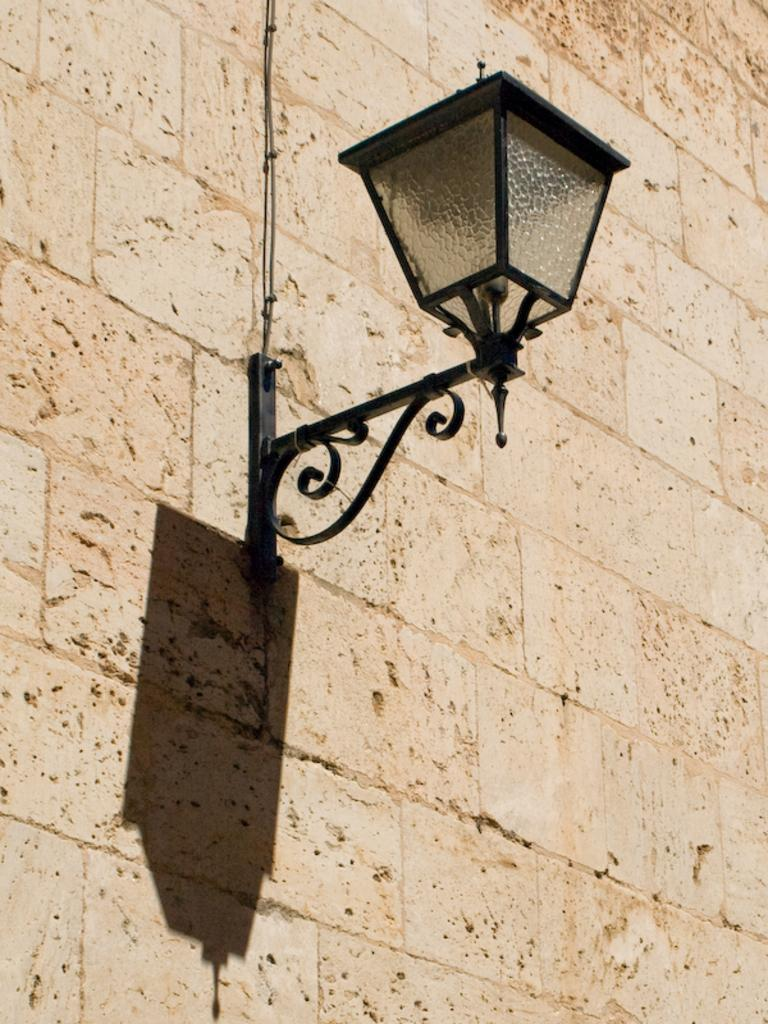What can be seen on the wall in the image? There is an electric light attached to the wall in the image. Can you describe the electric light? The electric light is attached to the wall. How many men are visible in the image? There are no men visible in the image; it only features a wall with an electric light attached to it. What time of day is it in the image, given the presence of frogs? There are no frogs present in the image, so it is not possible to determine the time of day based on their presence. 